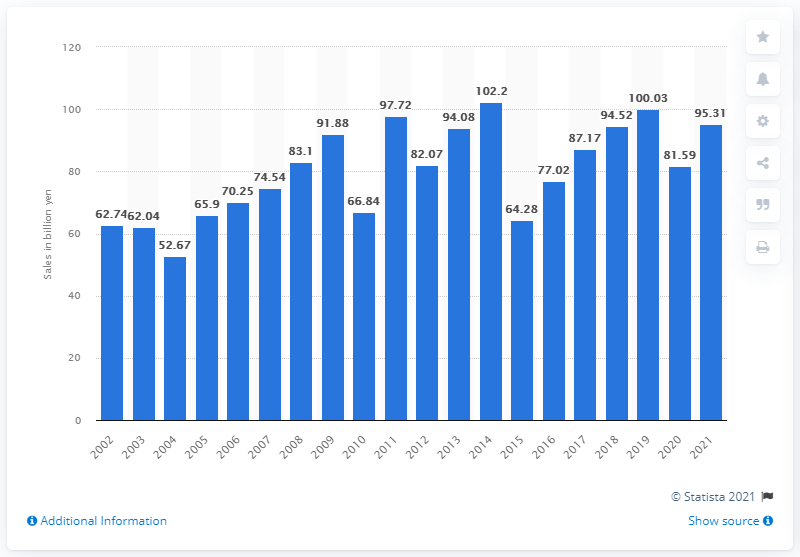Point out several critical features in this image. In fiscal year 2021, Capcom's net sales were 95,310 million Japanese yen. In the previous fiscal year, Capcom's net sales were 81,590 thousand yen. 